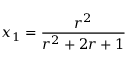Convert formula to latex. <formula><loc_0><loc_0><loc_500><loc_500>x _ { 1 } = \frac { r ^ { 2 } } { r ^ { 2 } + 2 r + 1 }</formula> 